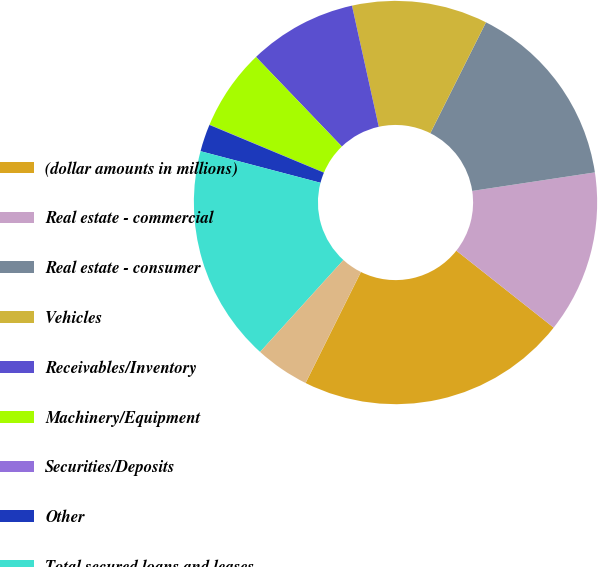Convert chart to OTSL. <chart><loc_0><loc_0><loc_500><loc_500><pie_chart><fcel>(dollar amounts in millions)<fcel>Real estate - commercial<fcel>Real estate - consumer<fcel>Vehicles<fcel>Receivables/Inventory<fcel>Machinery/Equipment<fcel>Securities/Deposits<fcel>Other<fcel>Total secured loans and leases<fcel>Unsecured loans and leases<nl><fcel>21.71%<fcel>13.04%<fcel>15.21%<fcel>10.87%<fcel>8.7%<fcel>6.53%<fcel>0.02%<fcel>2.19%<fcel>17.38%<fcel>4.36%<nl></chart> 